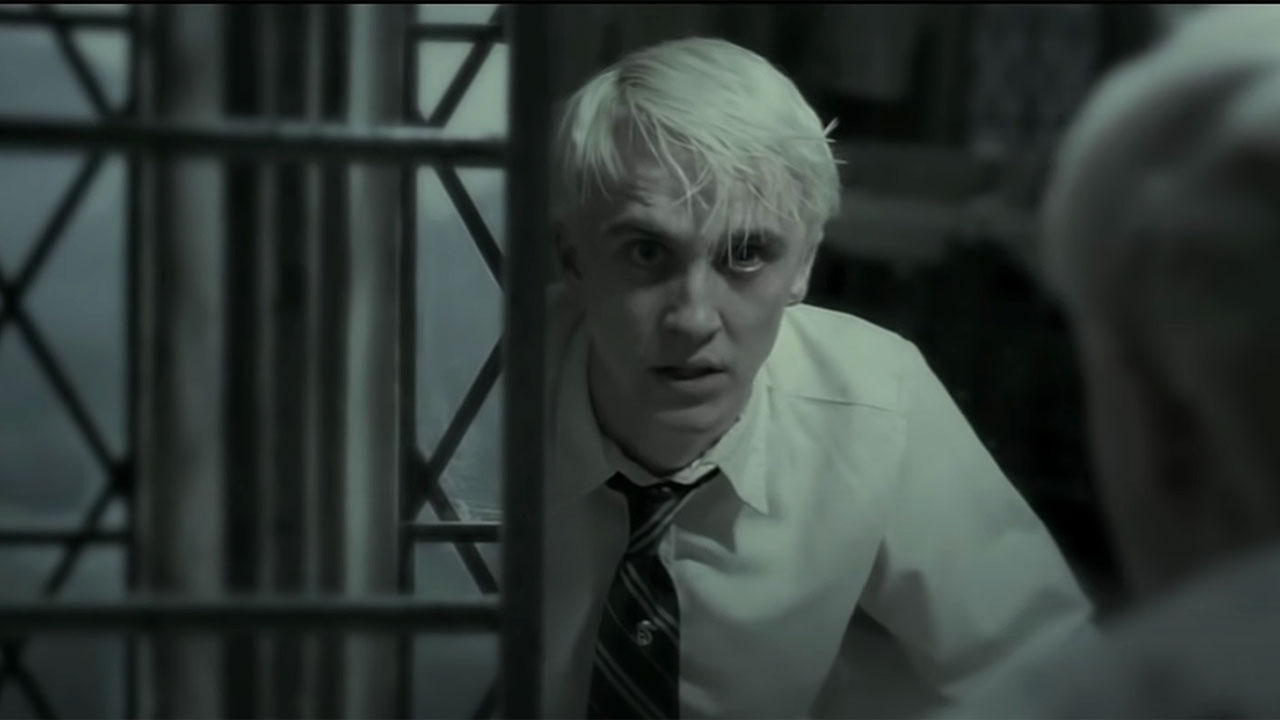Imagine this image is from a silent film era. Describe what's happening in old-timey terms. In the grayscale frame of an evocative silent film, we find young Draconis, a gentleman clad in his crisp, buttoned attire, gazing earnestly through the wrought-iron bars of a Victorian-style structure. His visage, etched with a gasp of surprise and forbearance, suggests he is on the cusp of discovering a harrowing truth. The flickers of his eyes dart back and forth, as a sweeping subtitle appears: 'Alas! The Secret Unveiled!' The entire scene conveys a poignant sense of suspense and drama, as melodramatic piano chords underscore the gravity of Draconis's plight. Perhaps he has stumbled upon a sinister plot, or uncovered a long-buried family secret, forever altering the course of his genteel existence. The image encapsulates a world of intrigue, awaiting the next dramatic reveal in this tale of yesteryear. 